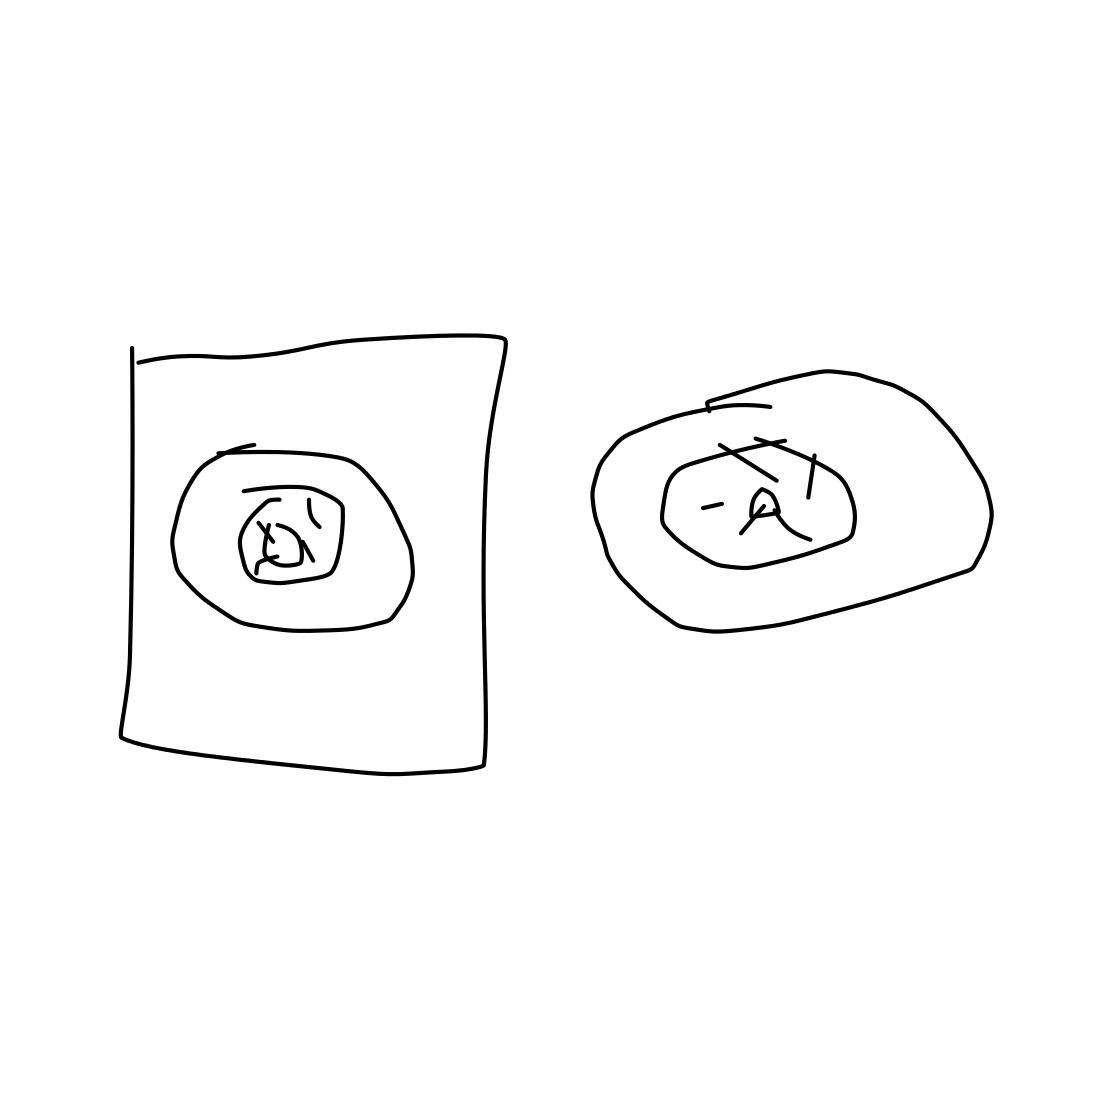What do you think these sketches are meant to represent? The sketches appear to be abstract representations, possibly of electronic devices given their shapes and the suggestion of speakers. They could symbolize early design concepts or simply be doodles with no specific intention. 